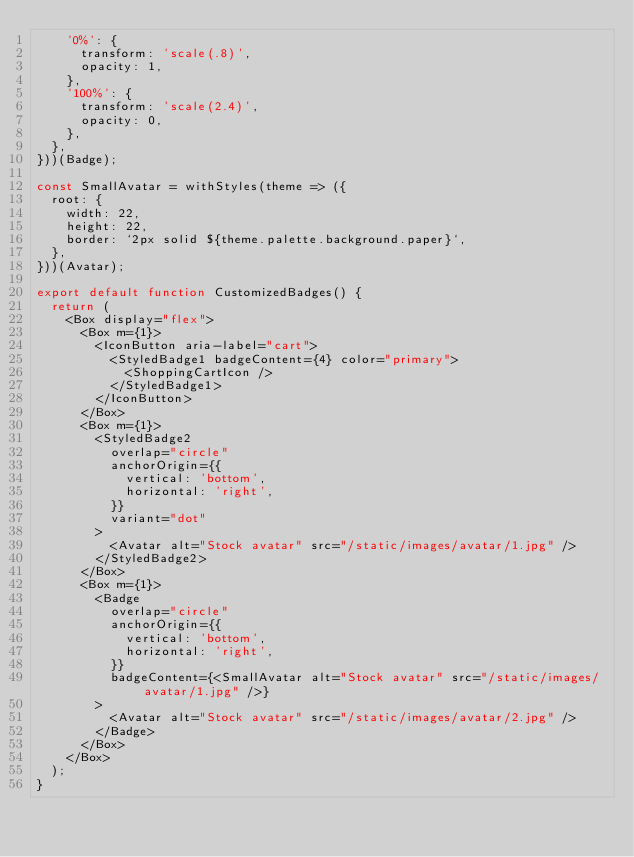Convert code to text. <code><loc_0><loc_0><loc_500><loc_500><_JavaScript_>    '0%': {
      transform: 'scale(.8)',
      opacity: 1,
    },
    '100%': {
      transform: 'scale(2.4)',
      opacity: 0,
    },
  },
}))(Badge);

const SmallAvatar = withStyles(theme => ({
  root: {
    width: 22,
    height: 22,
    border: `2px solid ${theme.palette.background.paper}`,
  },
}))(Avatar);

export default function CustomizedBadges() {
  return (
    <Box display="flex">
      <Box m={1}>
        <IconButton aria-label="cart">
          <StyledBadge1 badgeContent={4} color="primary">
            <ShoppingCartIcon />
          </StyledBadge1>
        </IconButton>
      </Box>
      <Box m={1}>
        <StyledBadge2
          overlap="circle"
          anchorOrigin={{
            vertical: 'bottom',
            horizontal: 'right',
          }}
          variant="dot"
        >
          <Avatar alt="Stock avatar" src="/static/images/avatar/1.jpg" />
        </StyledBadge2>
      </Box>
      <Box m={1}>
        <Badge
          overlap="circle"
          anchorOrigin={{
            vertical: 'bottom',
            horizontal: 'right',
          }}
          badgeContent={<SmallAvatar alt="Stock avatar" src="/static/images/avatar/1.jpg" />}
        >
          <Avatar alt="Stock avatar" src="/static/images/avatar/2.jpg" />
        </Badge>
      </Box>
    </Box>
  );
}
</code> 